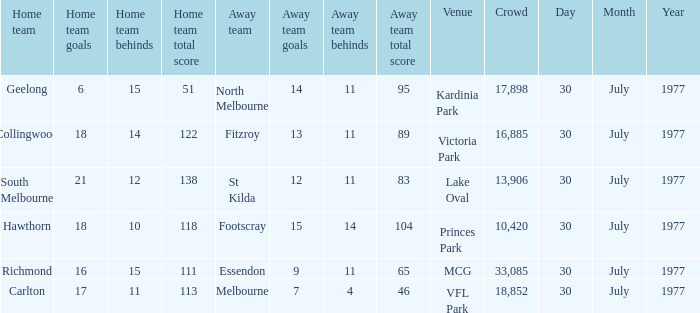What is north melbourne's score as a visiting team? 14.11 (95). 